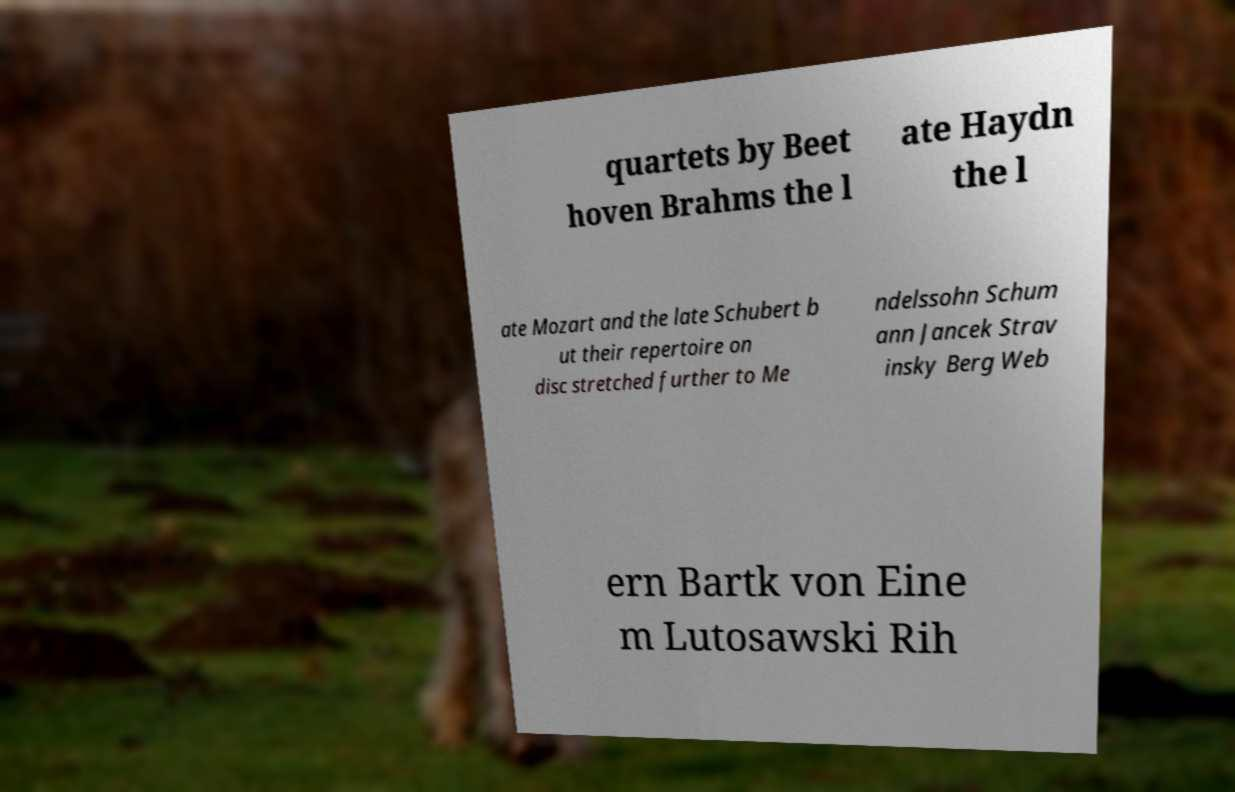What messages or text are displayed in this image? I need them in a readable, typed format. quartets by Beet hoven Brahms the l ate Haydn the l ate Mozart and the late Schubert b ut their repertoire on disc stretched further to Me ndelssohn Schum ann Jancek Strav insky Berg Web ern Bartk von Eine m Lutosawski Rih 